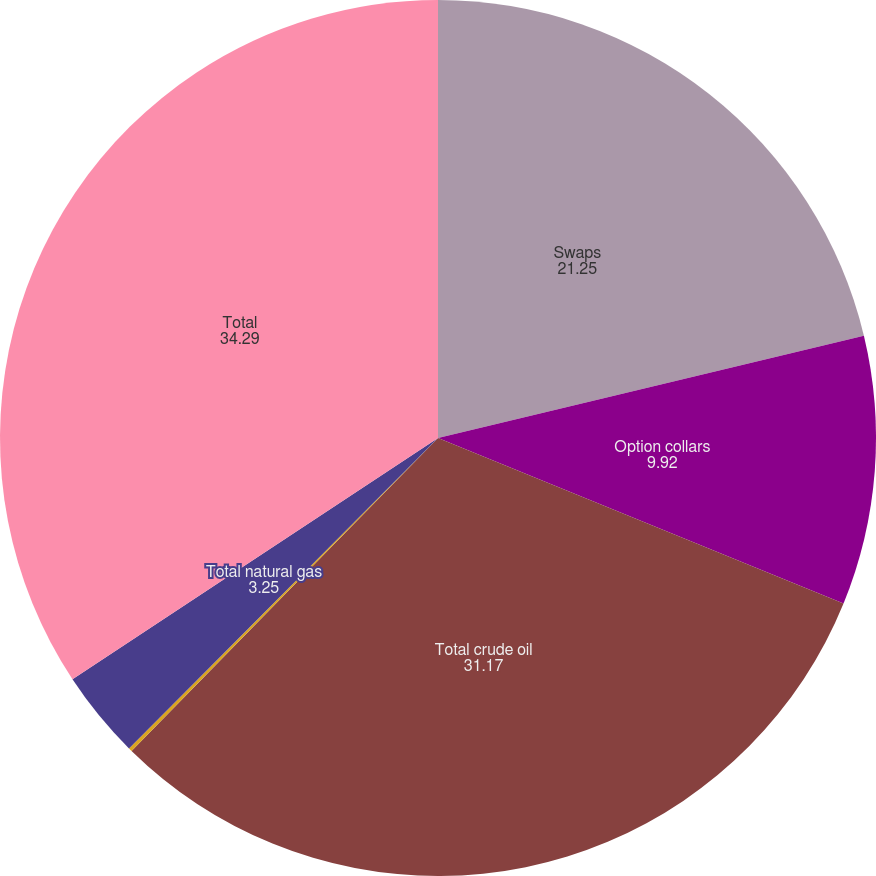Convert chart. <chart><loc_0><loc_0><loc_500><loc_500><pie_chart><fcel>Swaps<fcel>Option collars<fcel>Total crude oil<fcel>Futures<fcel>Total natural gas<fcel>Total<nl><fcel>21.25%<fcel>9.92%<fcel>31.17%<fcel>0.13%<fcel>3.25%<fcel>34.29%<nl></chart> 